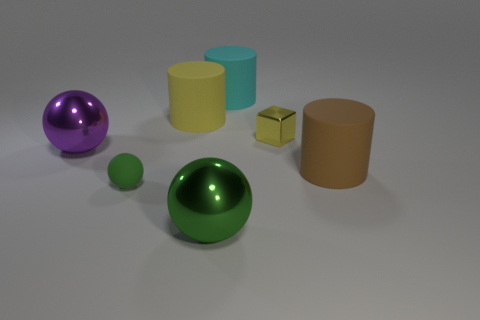Does the large brown thing have the same material as the small object to the right of the cyan thing?
Offer a very short reply. No. Is the number of big shiny things that are right of the big cyan thing the same as the number of shiny objects behind the purple thing?
Offer a terse response. No. There is a brown rubber cylinder; is its size the same as the green sphere that is on the left side of the large yellow object?
Offer a terse response. No. Are there more large things in front of the large brown cylinder than big red shiny objects?
Make the answer very short. Yes. How many cylinders are the same size as the purple shiny object?
Your answer should be compact. 3. There is a metallic object that is right of the cyan cylinder; does it have the same size as the metal ball that is in front of the big purple thing?
Your answer should be compact. No. Is the number of big rubber objects that are in front of the small yellow metal object greater than the number of cylinders that are left of the big purple metal object?
Your answer should be compact. Yes. How many green matte things are the same shape as the purple shiny thing?
Make the answer very short. 1. There is a purple object that is the same size as the brown thing; what is its material?
Your response must be concise. Metal. Are there any large brown cylinders made of the same material as the big cyan thing?
Ensure brevity in your answer.  Yes. 